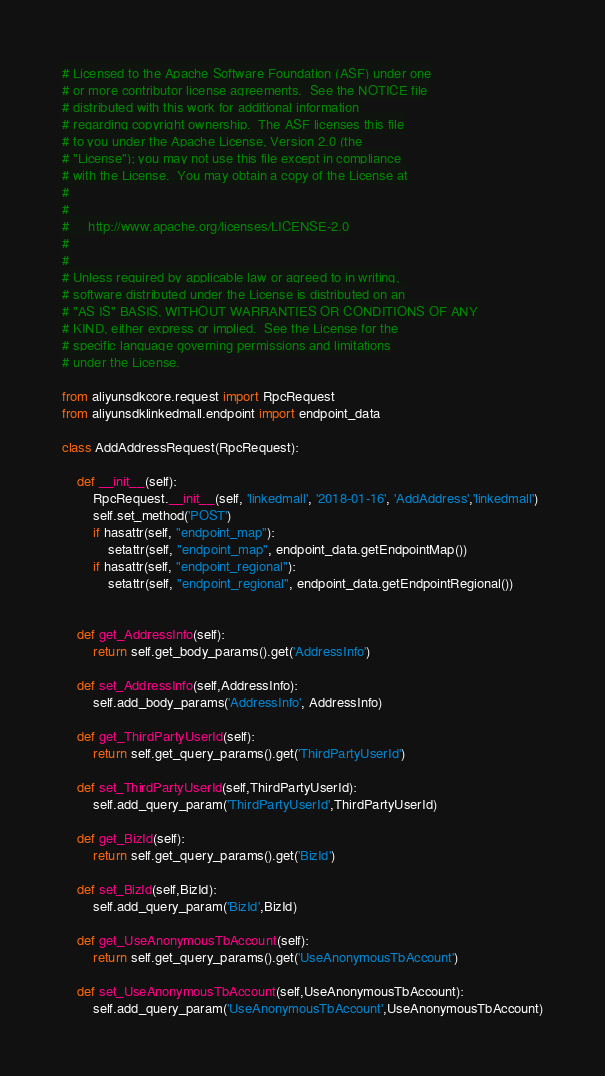<code> <loc_0><loc_0><loc_500><loc_500><_Python_># Licensed to the Apache Software Foundation (ASF) under one
# or more contributor license agreements.  See the NOTICE file
# distributed with this work for additional information
# regarding copyright ownership.  The ASF licenses this file
# to you under the Apache License, Version 2.0 (the
# "License"); you may not use this file except in compliance
# with the License.  You may obtain a copy of the License at
#
#
#     http://www.apache.org/licenses/LICENSE-2.0
#
#
# Unless required by applicable law or agreed to in writing,
# software distributed under the License is distributed on an
# "AS IS" BASIS, WITHOUT WARRANTIES OR CONDITIONS OF ANY
# KIND, either express or implied.  See the License for the
# specific language governing permissions and limitations
# under the License.

from aliyunsdkcore.request import RpcRequest
from aliyunsdklinkedmall.endpoint import endpoint_data

class AddAddressRequest(RpcRequest):

	def __init__(self):
		RpcRequest.__init__(self, 'linkedmall', '2018-01-16', 'AddAddress','linkedmall')
		self.set_method('POST')
		if hasattr(self, "endpoint_map"):
			setattr(self, "endpoint_map", endpoint_data.getEndpointMap())
		if hasattr(self, "endpoint_regional"):
			setattr(self, "endpoint_regional", endpoint_data.getEndpointRegional())


	def get_AddressInfo(self):
		return self.get_body_params().get('AddressInfo')

	def set_AddressInfo(self,AddressInfo):
		self.add_body_params('AddressInfo', AddressInfo)

	def get_ThirdPartyUserId(self):
		return self.get_query_params().get('ThirdPartyUserId')

	def set_ThirdPartyUserId(self,ThirdPartyUserId):
		self.add_query_param('ThirdPartyUserId',ThirdPartyUserId)

	def get_BizId(self):
		return self.get_query_params().get('BizId')

	def set_BizId(self,BizId):
		self.add_query_param('BizId',BizId)

	def get_UseAnonymousTbAccount(self):
		return self.get_query_params().get('UseAnonymousTbAccount')

	def set_UseAnonymousTbAccount(self,UseAnonymousTbAccount):
		self.add_query_param('UseAnonymousTbAccount',UseAnonymousTbAccount)</code> 